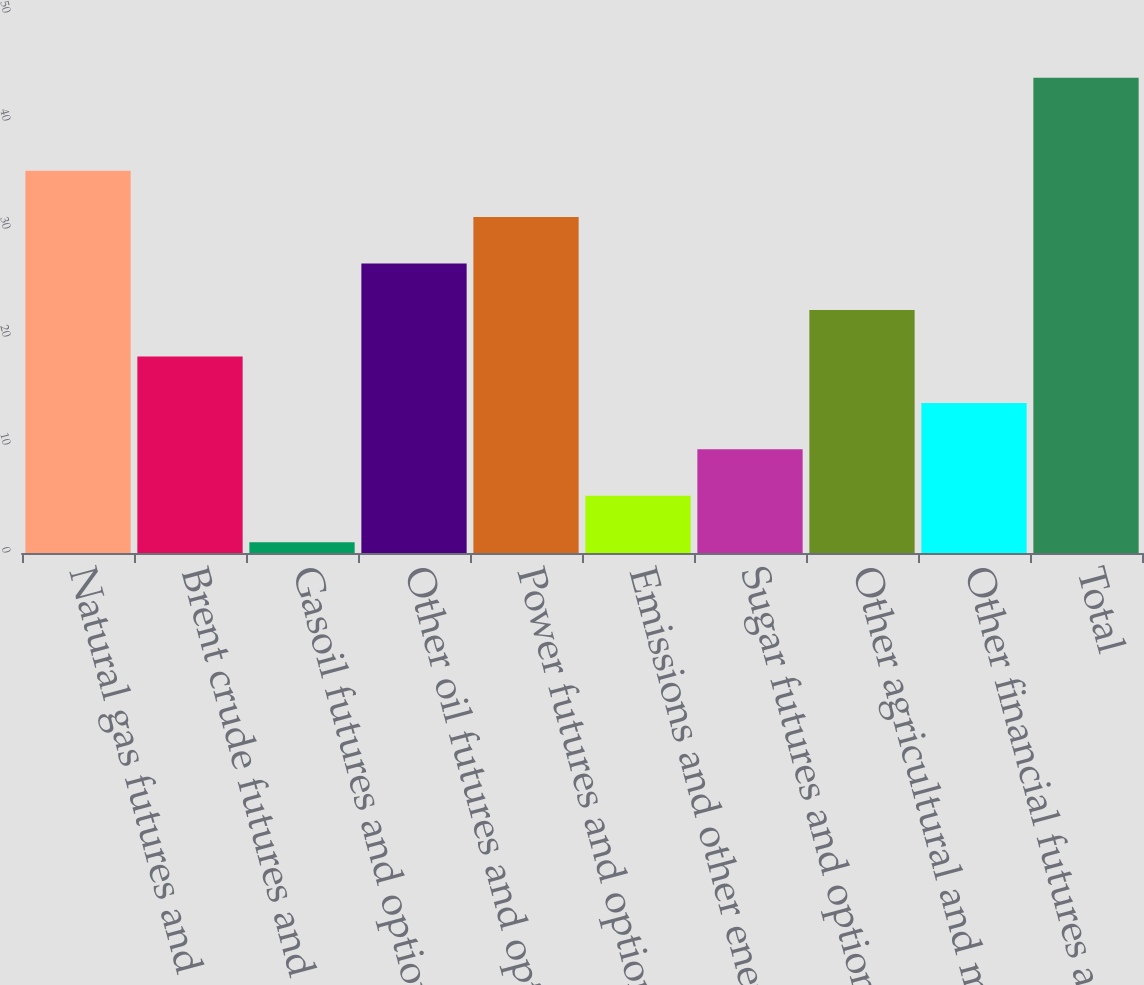<chart> <loc_0><loc_0><loc_500><loc_500><bar_chart><fcel>Natural gas futures and<fcel>Brent crude futures and<fcel>Gasoil futures and options<fcel>Other oil futures and options<fcel>Power futures and options<fcel>Emissions and other energy<fcel>Sugar futures and options<fcel>Other agricultural and metals<fcel>Other financial futures and<fcel>Total<nl><fcel>35.4<fcel>18.2<fcel>1<fcel>26.8<fcel>31.1<fcel>5.3<fcel>9.6<fcel>22.5<fcel>13.9<fcel>44<nl></chart> 